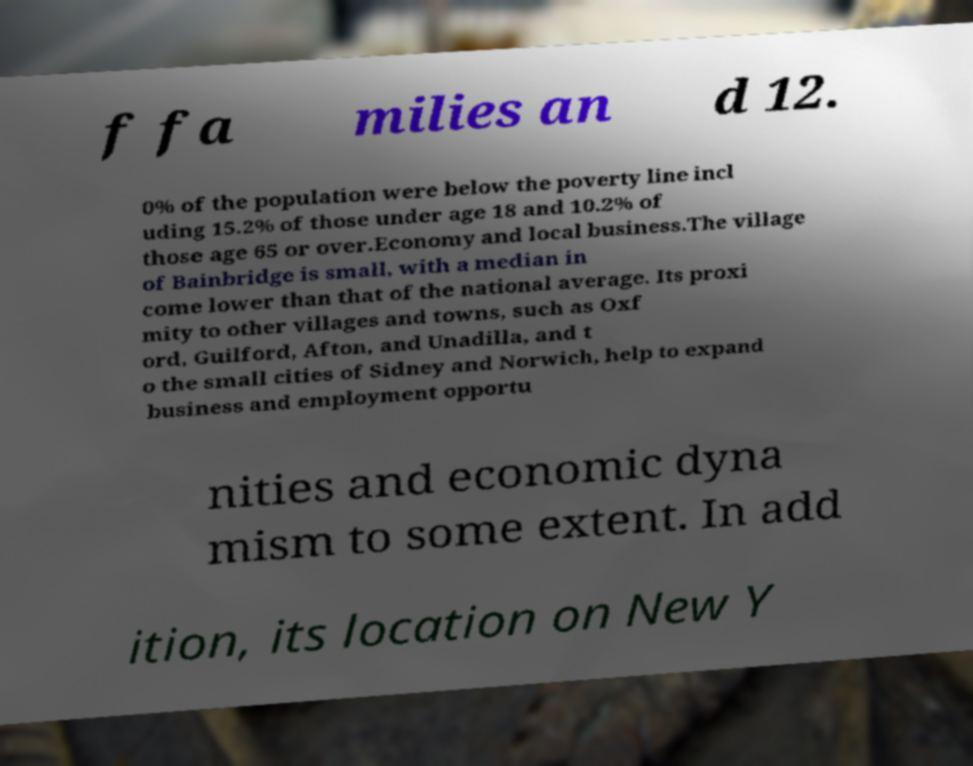For documentation purposes, I need the text within this image transcribed. Could you provide that? f fa milies an d 12. 0% of the population were below the poverty line incl uding 15.2% of those under age 18 and 10.2% of those age 65 or over.Economy and local business.The village of Bainbridge is small, with a median in come lower than that of the national average. Its proxi mity to other villages and towns, such as Oxf ord, Guilford, Afton, and Unadilla, and t o the small cities of Sidney and Norwich, help to expand business and employment opportu nities and economic dyna mism to some extent. In add ition, its location on New Y 